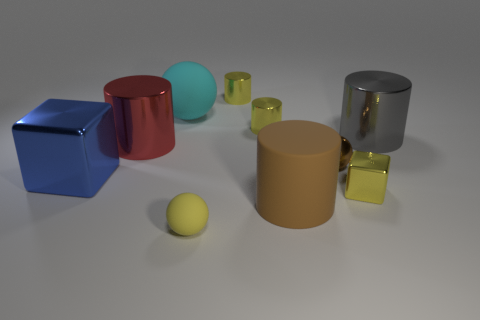Is there a tiny brown object made of the same material as the big gray thing?
Your answer should be compact. Yes. What material is the blue block that is the same size as the cyan rubber ball?
Give a very brief answer. Metal. Is the number of large gray metallic things that are left of the large cyan rubber thing less than the number of brown rubber cylinders behind the brown metal object?
Provide a short and direct response. No. What is the shape of the large object that is both to the right of the small yellow matte ball and behind the small yellow cube?
Ensure brevity in your answer.  Cylinder. What number of other small things have the same shape as the blue object?
Your answer should be very brief. 1. What size is the red cylinder that is made of the same material as the gray thing?
Ensure brevity in your answer.  Large. Are there more shiny cubes than big gray things?
Make the answer very short. Yes. There is a big metal cylinder that is on the right side of the yellow rubber thing; what is its color?
Offer a very short reply. Gray. What is the size of the thing that is to the left of the big gray cylinder and right of the tiny shiny ball?
Ensure brevity in your answer.  Small. How many brown rubber things are the same size as the brown rubber cylinder?
Provide a succinct answer. 0. 